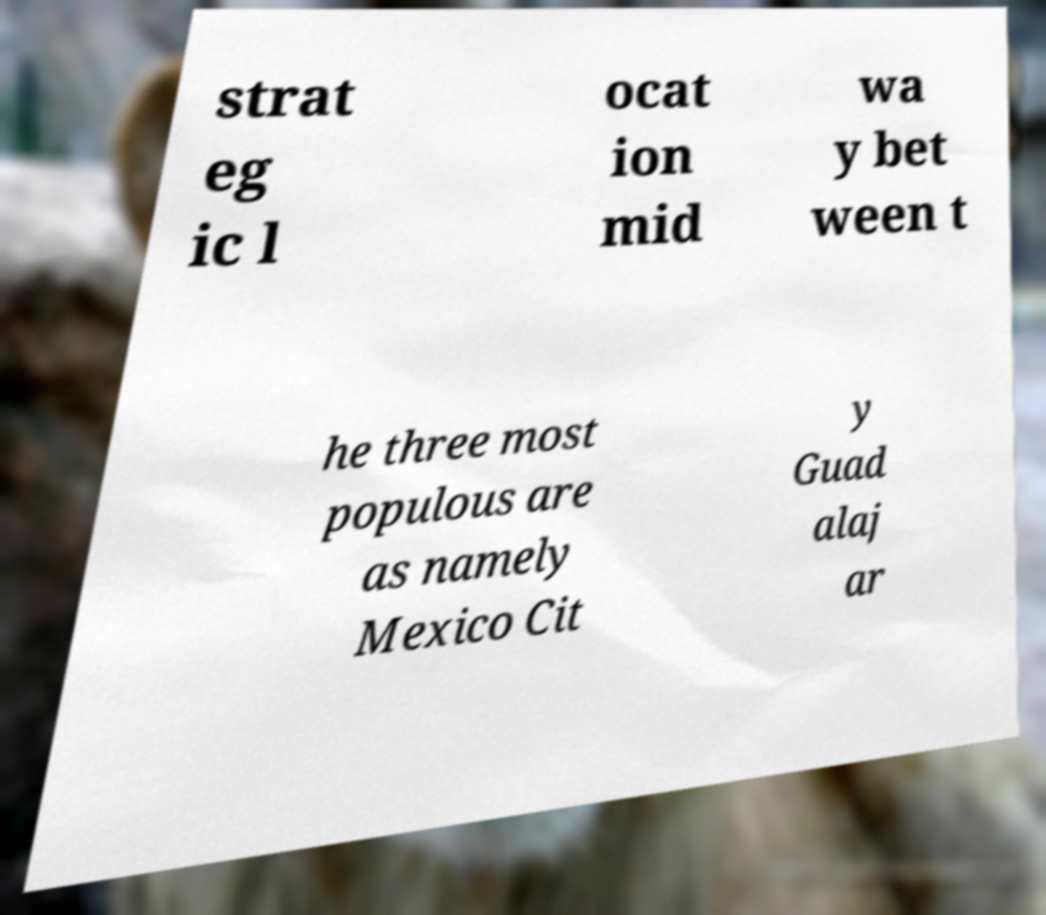Please identify and transcribe the text found in this image. strat eg ic l ocat ion mid wa y bet ween t he three most populous are as namely Mexico Cit y Guad alaj ar 